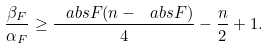Convert formula to latex. <formula><loc_0><loc_0><loc_500><loc_500>\frac { \beta _ { F } } { \alpha _ { F } } \geq \frac { \ a b s { F } ( n - \ a b s { F } ) } { 4 } - \frac { n } { 2 } + 1 .</formula> 